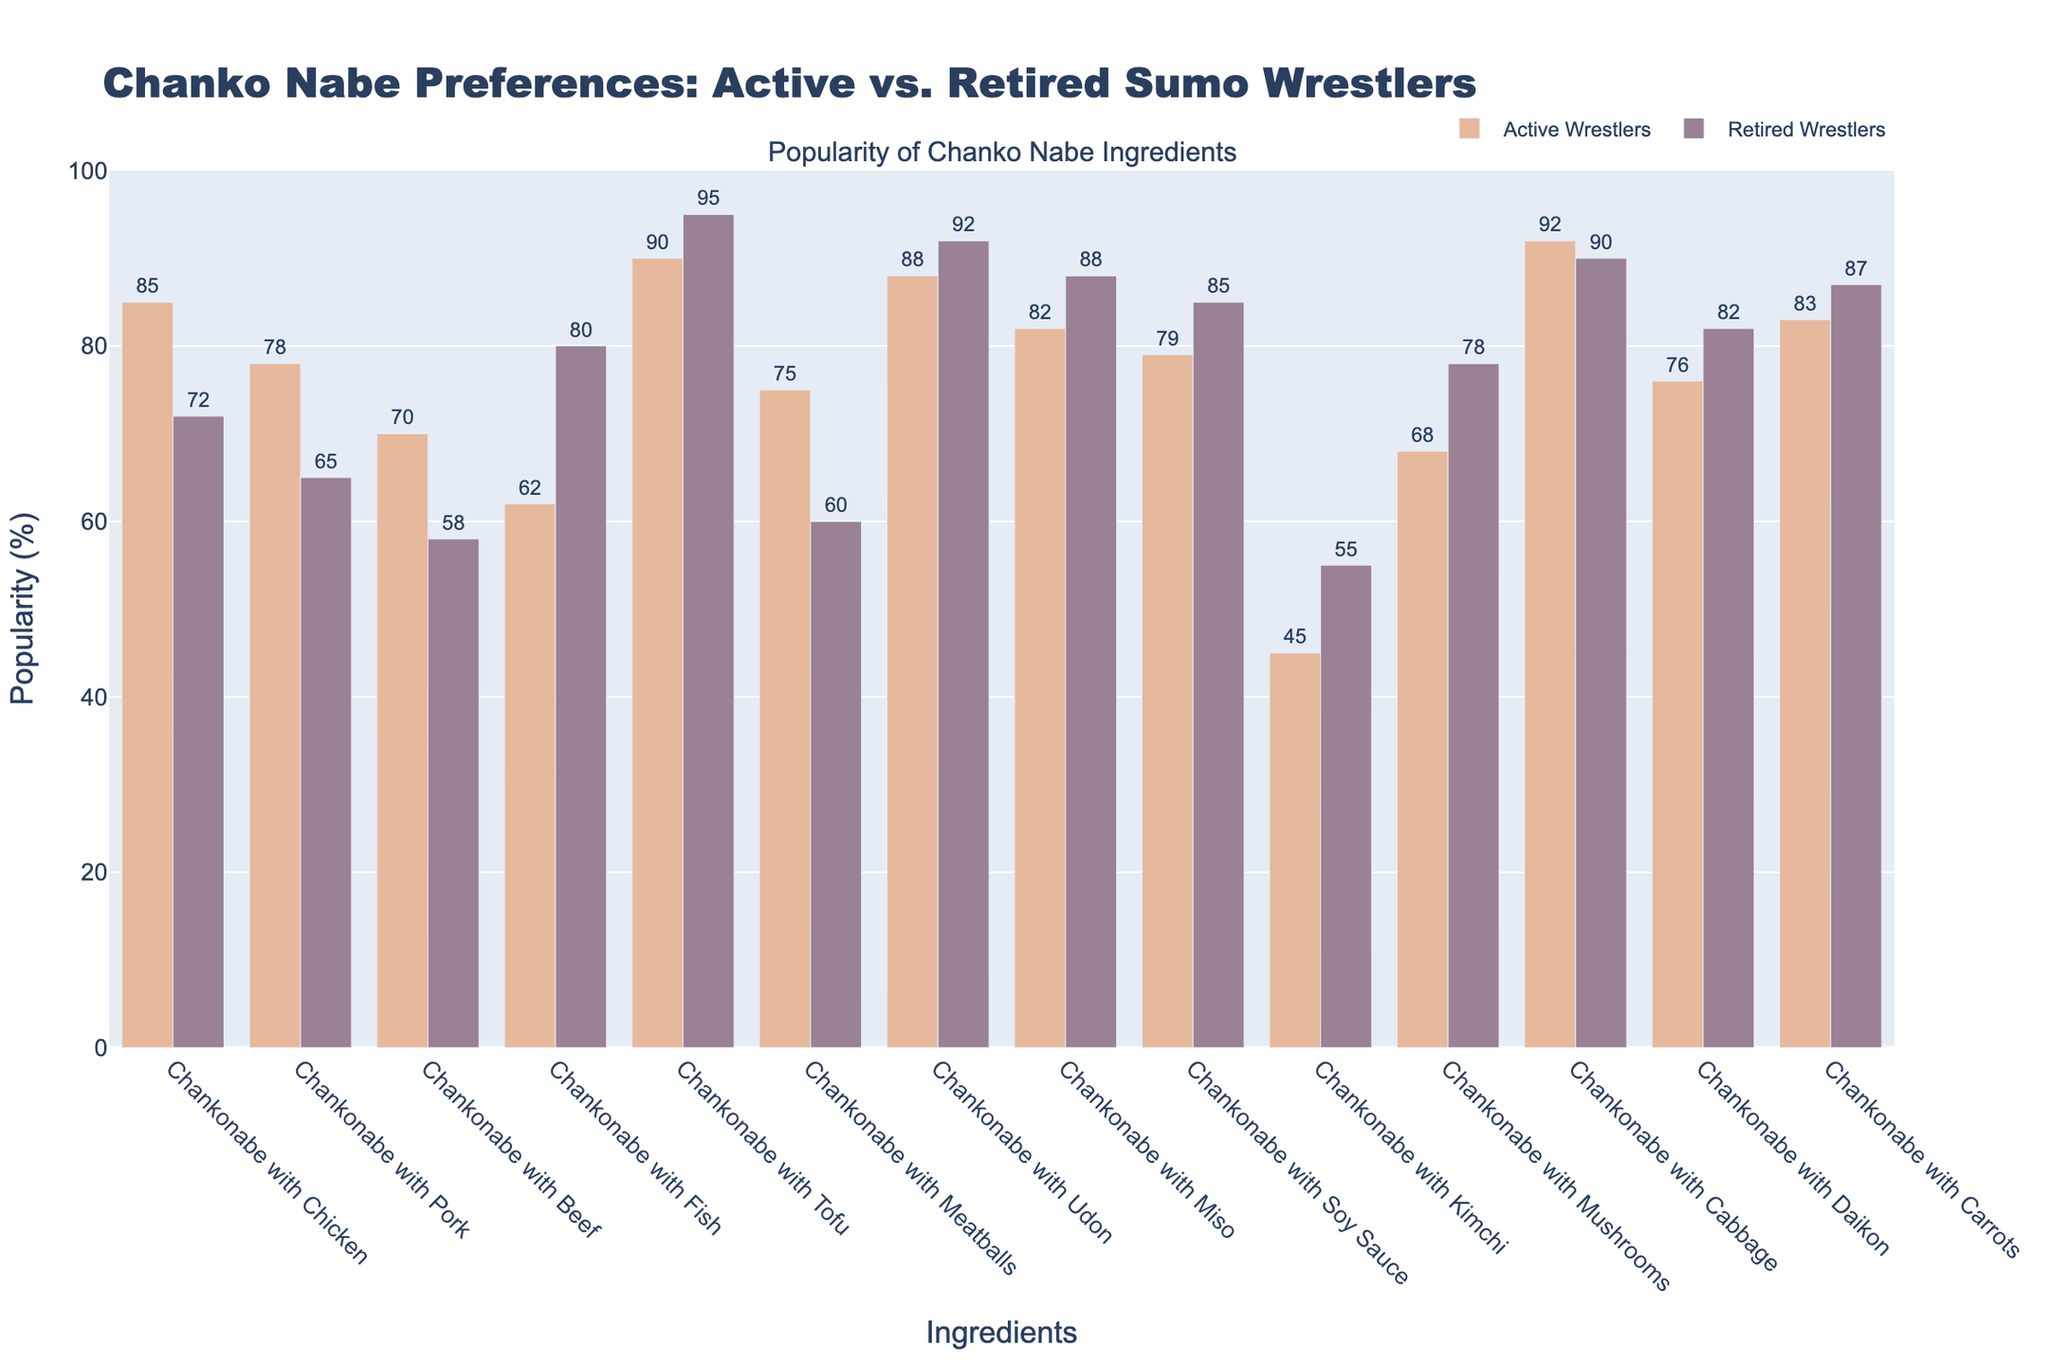Which ingredient is the most popular among active wrestlers? The bar for "Chankonabe with Tofu" rises the highest for active wrestlers.
Answer: Chankonabe with Tofu Which ingredient shows the greatest difference in popularity between active and retired wrestlers? Subtract the popularity percentages of active and retired wrestlers for each ingredient and find the largest difference. For "Chankonabe with Meatballs," the difference is 75% - 60% = 15%.
Answer: Chankonabe with Meatballs Which ingredient is more popular among retired wrestlers than active wrestlers? Compare the heights of the bars for each ingredient. Only "Chankonabe with Fish" has a higher bar for retired wrestlers (80%) than for active wrestlers (62%).
Answer: Chankonabe with Fish What is the average popularity of Chankonabe with Chicken, Pork, and Beef among active wrestlers? Add the popularity percentages: 85% (Chicken) + 78% (Pork) + 70% (Beef) = 233%. Divide by 3 to get the average: 233% / 3 = 77.67%.
Answer: 77.67% Is Chankonabe with Mushrooms more popular among active or retired wrestlers? Compare the heights of the bars for "Chankonabe with Mushrooms," where active wrestlers are at 68% and retired wrestlers are at 78%.
Answer: Retired wrestlers What's the difference in popularity of Chankonabe with Tofu between active and retired wrestlers? Subtract the popularity percentages: 95% (Retired) - 90% (Active) = 5%.
Answer: 5% Which ingredient has the smallest difference in popularity between active and retired wrestlers? Calculate the differences for each ingredient. For "Chankonabe with Cabbage," the difference is 92% - 90% = 2%.
Answer: Chankonabe with Cabbage How many ingredients are equally or more popular among retired wrestlers compared to active wrestlers? Count the ingredients where the retired wrestlers' bars are equal to or taller than those of active wrestlers. These are "Chankonabe with Fish," "Chankonabe with Tofu," "Chankonabe with Udon," "Chankonabe with Miso," "Chankonabe with Soy Sauce," "Chankonabe with Cabbage," and "Chankonabe with Daikon." There are 7 in total.
Answer: 7 